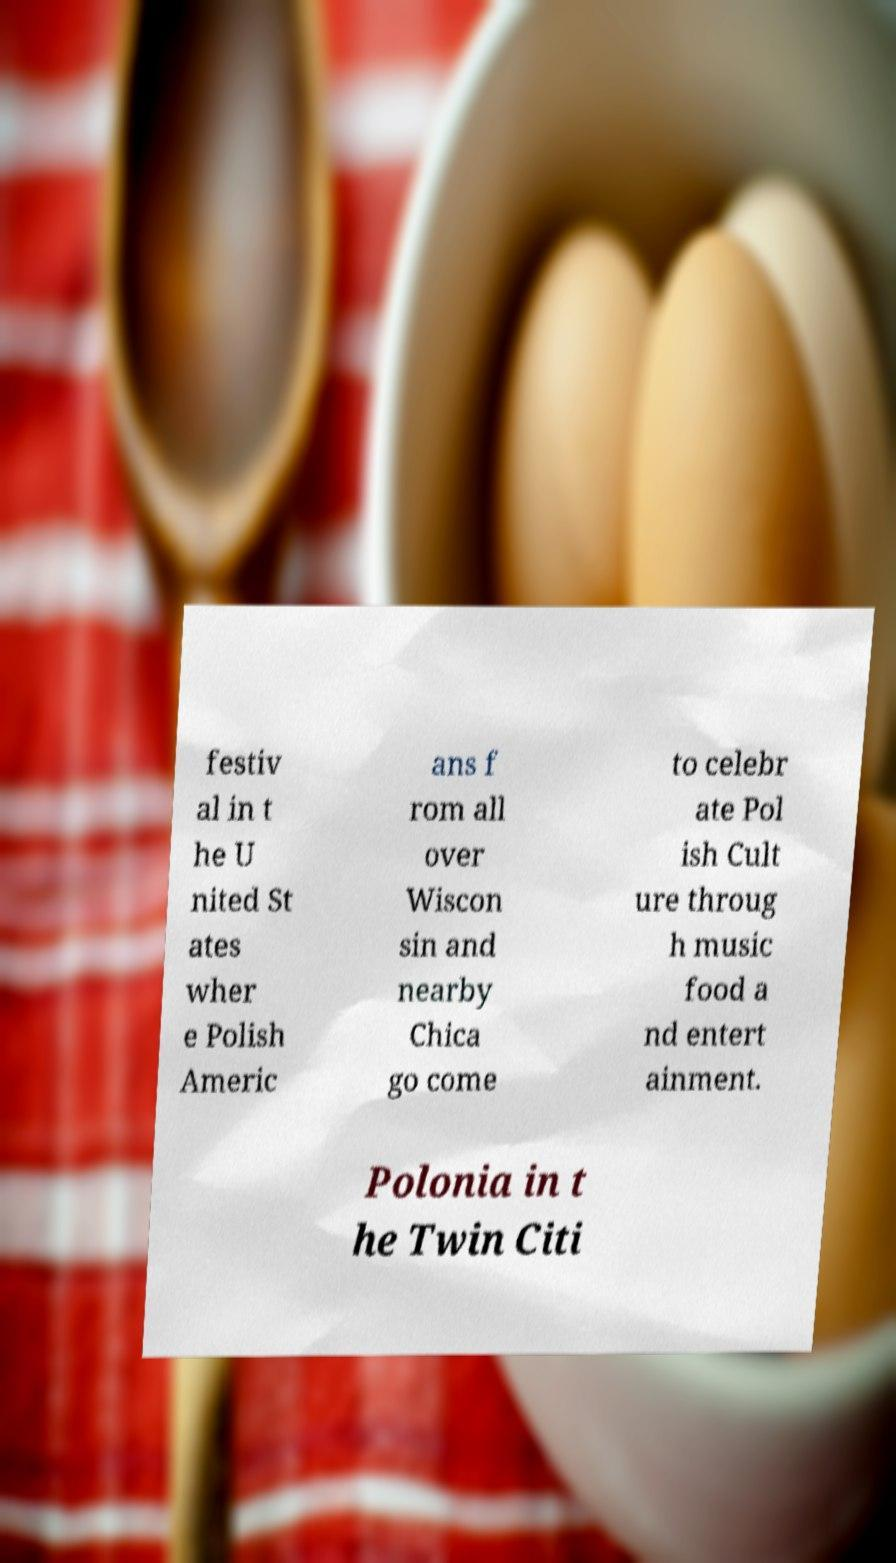I need the written content from this picture converted into text. Can you do that? festiv al in t he U nited St ates wher e Polish Americ ans f rom all over Wiscon sin and nearby Chica go come to celebr ate Pol ish Cult ure throug h music food a nd entert ainment. Polonia in t he Twin Citi 